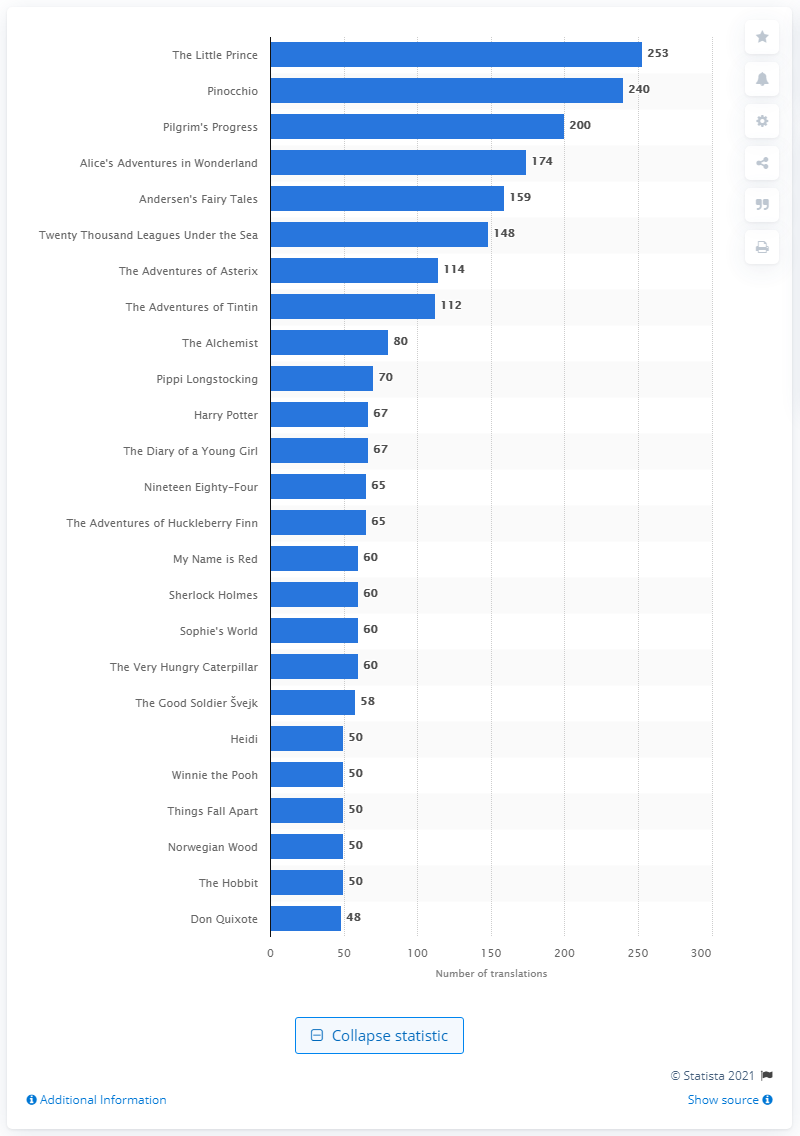Give some essential details in this illustration. The French novella "The Little Prince" has 253 translations. 